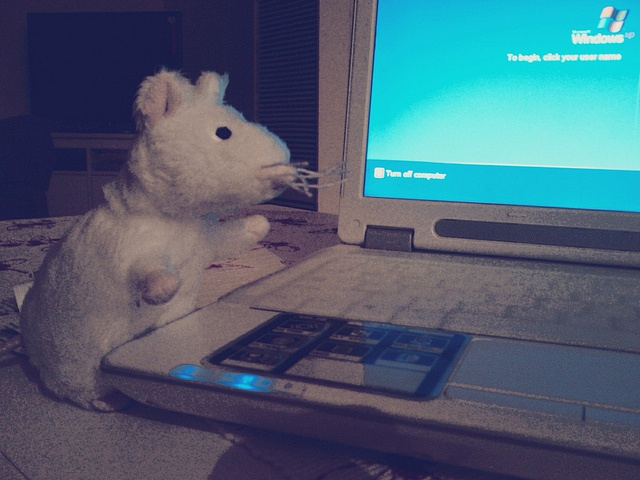Describe the objects in this image and their specific colors. I can see laptop in navy, gray, and turquoise tones, teddy bear in navy and gray tones, bed in navy, gray, and purple tones, and tv in navy and purple tones in this image. 